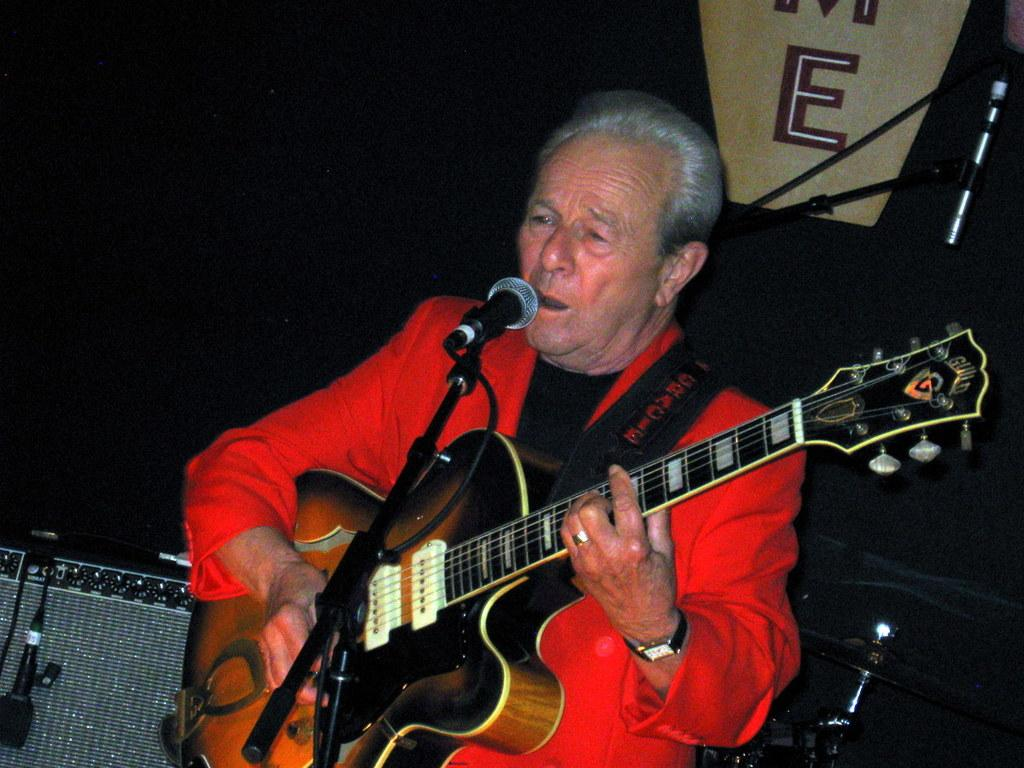Who is the main subject in the image? There is a man in the image. What is the man holding in the image? The man is holding a guitar. What is the man doing with the guitar? The man is singing a song. What objects are present in the image that might be used for amplifying sound? There are microphones in the image. How many sisters are present in the image? There are no sisters mentioned or visible in the image. What type of ornament is hanging from the guitar in the image? There is no ornament hanging from the guitar in the image. 